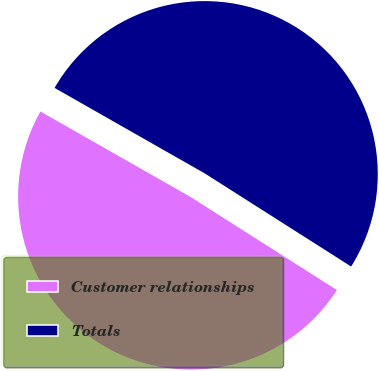Convert chart. <chart><loc_0><loc_0><loc_500><loc_500><pie_chart><fcel>Customer relationships<fcel>Totals<nl><fcel>49.22%<fcel>50.78%<nl></chart> 